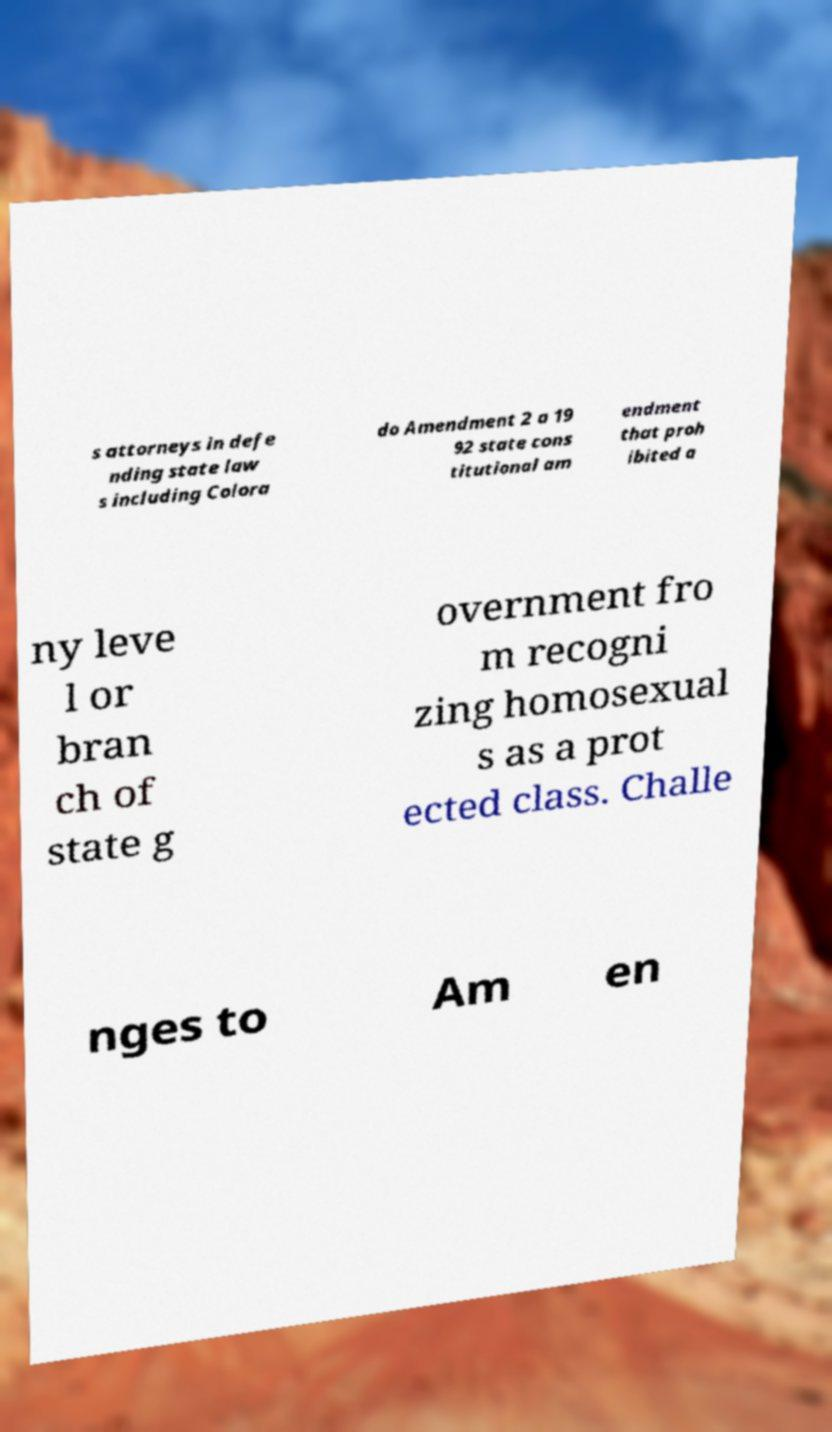Can you read and provide the text displayed in the image?This photo seems to have some interesting text. Can you extract and type it out for me? s attorneys in defe nding state law s including Colora do Amendment 2 a 19 92 state cons titutional am endment that proh ibited a ny leve l or bran ch of state g overnment fro m recogni zing homosexual s as a prot ected class. Challe nges to Am en 